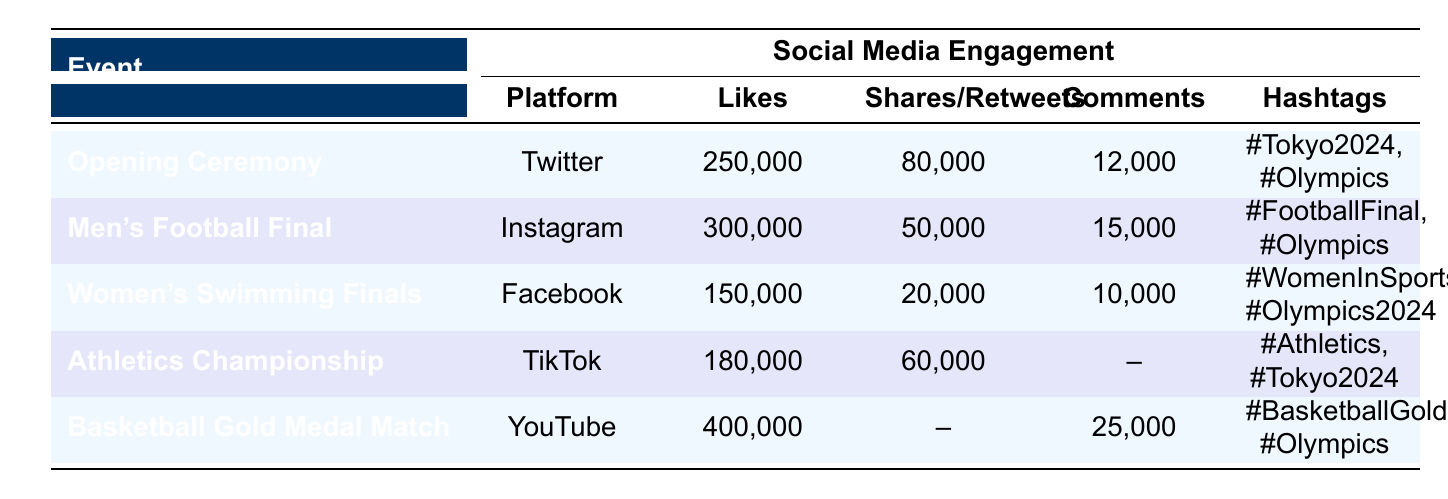What event had the highest likes? The event with the highest likes is the Basketball Gold Medal Match, which received 400,000 likes on YouTube.
Answer: Basketball Gold Medal Match How many shares/retweets does the Women's Swimming Finals have? The Women's Swimming Finals had 20,000 shares on Facebook.
Answer: 20,000 What is the total number of likes for the Opening Ceremony and Men's Football Final? The likes for the Opening Ceremony are 250,000, and for the Men's Football Final, they are 300,000. Summing these gives 250,000 + 300,000 = 550,000 likes.
Answer: 550,000 Is it true that the Athletics Championship has comments recorded? The Athletics Championship does not have any recorded comments, as indicated by the dash in the comments column.
Answer: No Which social media platform had the most engagement in terms of likes? The YouTube platform for the Basketball Gold Medal Match had the most engagement with 400,000 likes.
Answer: YouTube What is the average number of likes across all events listed? The total likes are 1,250,000 (250,000 + 300,000 + 150,000 + 180,000 + 400,000), and there are 5 events. The average is 1,250,000 / 5 = 250,000 likes.
Answer: 250,000 Which event had the least number of likes and how many was that? The event with the least likes is the Women's Swimming Finals, with 150,000 likes.
Answer: Women's Swimming Finals, 150,000 Do all events utilize hashtags? Yes, all events listed have at least one hashtag associated with them as seen in the hashtags column.
Answer: Yes 